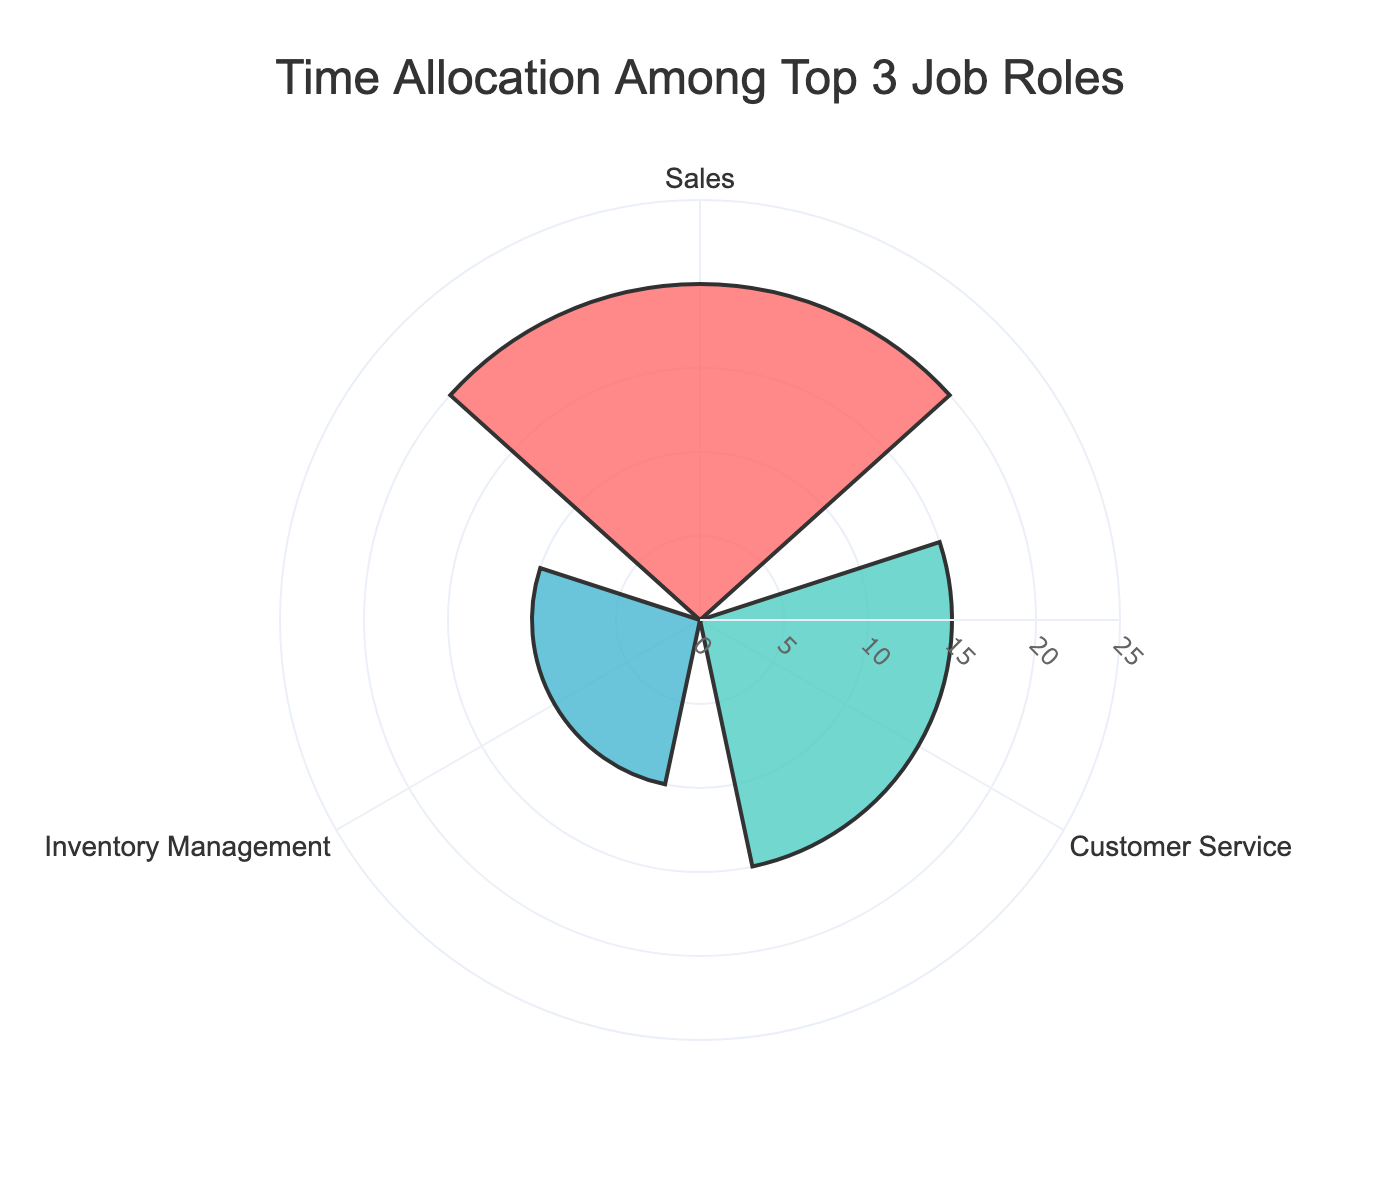What is the title of the rose chart? The title is located at the top of the figure. It states what the chart is about, which can normally be seen visibly.
Answer: Time Allocation Among Top 3 Job Roles What are the job roles represented in the chart? The job roles are labeled around the outer ring of the chart and correspond to each petal of the rose chart.
Answer: Customer Service, Inventory Management, Sales Which job role has the highest hours per week? The tallest or most extended petal in the chart indicates the job role with the highest hours per week.
Answer: Sales How many hours per week are allocated to Inventory Management? Look for the length of the petal labeled as Inventory Management to determine the hours.
Answer: 10 hours Which color represents Customer Service on the chart? Identify Customer Service in the chart and note its petal color.
Answer: Red (or #FF6B6B) What is the sum of hours for Customer Service and Inventory Management? Add the values of the petals labeled Customer Service and Inventory Management.
Answer: 25 hours By how many hours does Sales exceed Inventory Management? Subtract the hours allocated to Inventory Management from the hours allocated to Sales.
Answer: 10 hours What is the average number of hours allocated to the top 3 job roles? Sum the hours of the top 3 job roles and divide by 3.
Answer: (20 + 15 + 10) / 3 = 15 hours Compare the allocation of hours between Customer Service and Sales. Determine if the hours for Customer Service are more, less, or the same compared to Sales.
Answer: Less Is Administration included in the rose chart? Check if Administration is one of the job roles displayed by looking at the labels on the rose chart.
Answer: No 